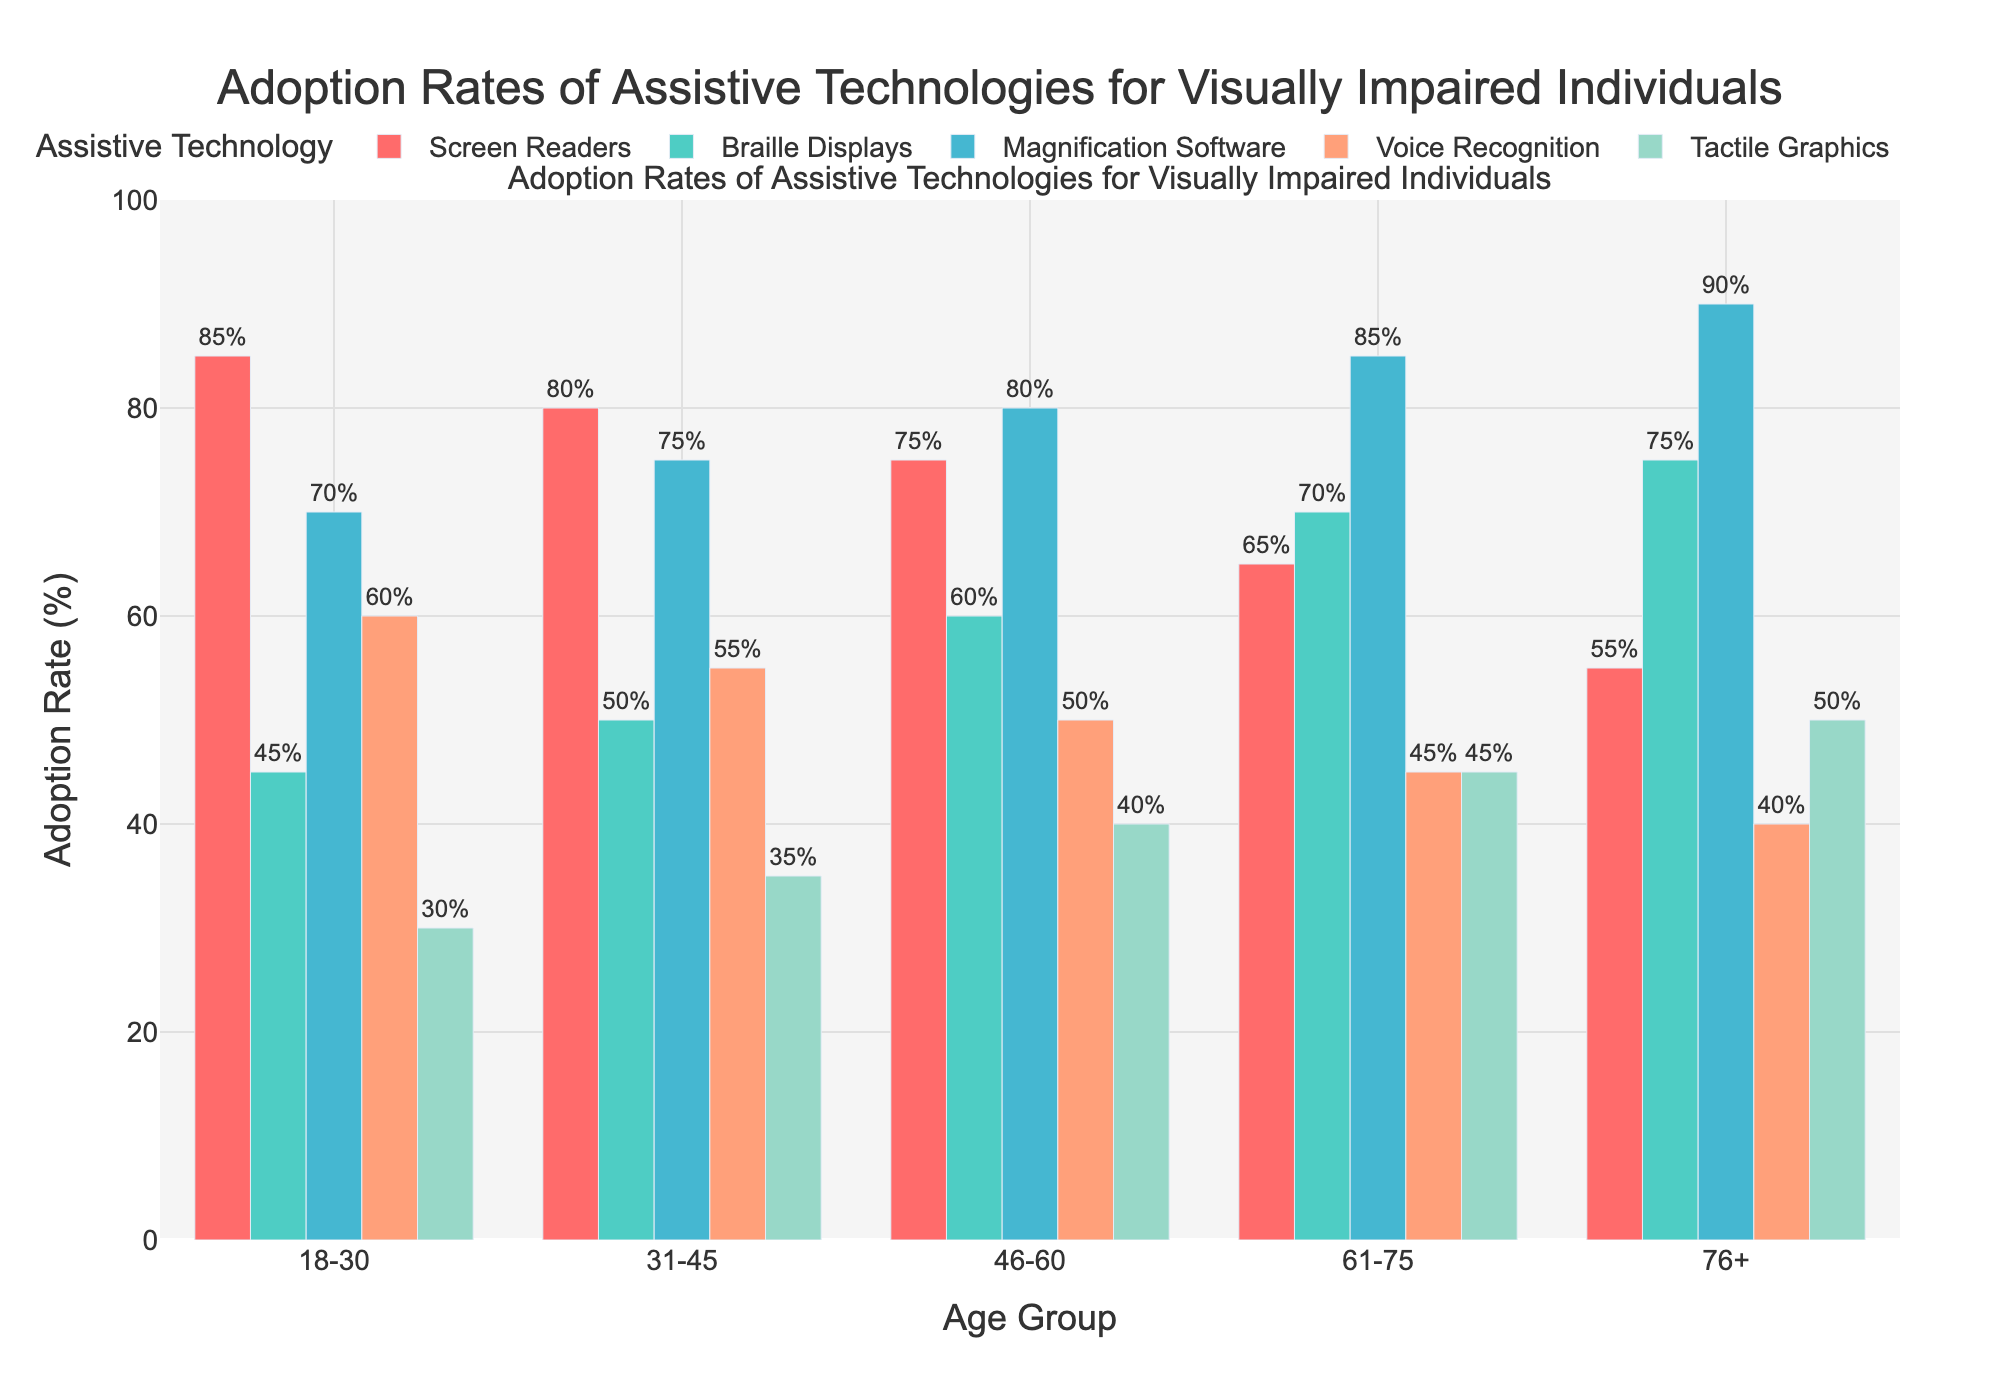What is the adoption rate of Braille Displays for the age group 61-75? To find this information, look for the bar representing Braille Displays (colored differently from the others, likely green). Locate the bar for the age group 61-75 and read the value associated with it.
Answer: 70% Which age group shows the highest adoption rate for Voice Recognition? Compare the heights of the bars representing Voice Recognition (another distinct color). Identify the tallest bar and note the corresponding age group.
Answer: 18-30 How does the adoption rate of Magnification Software compare between the age groups 18-30 and 76+? Locate the bars for Magnification Software (again with a distinct color) for both age groups. Compare the heights or the values given on the bars.
Answer: 18-30: 70%, 76+: 90% What is the average adoption rate of Tactile Graphics across all age groups? Sum the adoption rates of Tactile Graphics for all age groups and divide by the number of age groups (5). Calculation: (30 + 35 + 40 + 45 + 50) / 5.
Answer: 40% For the 31-45 age group, which assistive technology has the lowest adoption rate? Look at the bars for the age group 31-45 and identify the shortest bar.
Answer: Tactile Graphics Is there a consistent trend in the adoption rates of Screen Readers across increasing age groups? Observe the heights of the bars for Screen Readers across all age groups and determine if there's a consistent increase, decrease, or no clear trend overall.
Answer: Decreasing trend What is the total adoption rate of all assistive technologies for the age group 46-60? Add the adoption rates of all assistive technologies for 46-60. Calculation: 75 + 60 + 80 + 50 + 40.
Answer: 305% How much higher is the adoption rate of Braille Displays in the 76+ age group compared to the 18-30 age group? Subtract the adoption rate of Braille Displays for the age group 18-30 from that for 76+. Calculation: 75% - 45%.
Answer: 30% Which assistive technology shows the least variation in adoption rates across different age groups? Compare the range of adoption rates for each assistive technology across all age groups. Identify the technology with the smallest difference between its highest and lowest adoption rates.
Answer: Tactile Graphics What pattern can be observed in the adoption rates of Magnification Software as age increases? Review the bars for Magnification Software across age groups.
Answer: Increasing trend 